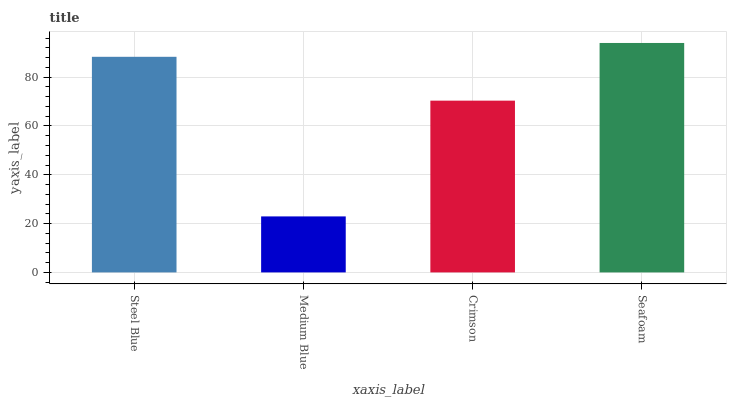Is Medium Blue the minimum?
Answer yes or no. Yes. Is Seafoam the maximum?
Answer yes or no. Yes. Is Crimson the minimum?
Answer yes or no. No. Is Crimson the maximum?
Answer yes or no. No. Is Crimson greater than Medium Blue?
Answer yes or no. Yes. Is Medium Blue less than Crimson?
Answer yes or no. Yes. Is Medium Blue greater than Crimson?
Answer yes or no. No. Is Crimson less than Medium Blue?
Answer yes or no. No. Is Steel Blue the high median?
Answer yes or no. Yes. Is Crimson the low median?
Answer yes or no. Yes. Is Medium Blue the high median?
Answer yes or no. No. Is Seafoam the low median?
Answer yes or no. No. 